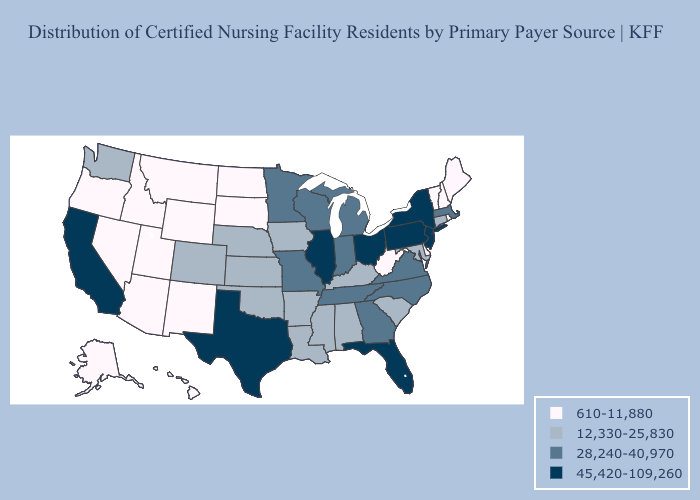What is the value of California?
Concise answer only. 45,420-109,260. Does the first symbol in the legend represent the smallest category?
Write a very short answer. Yes. What is the highest value in states that border Washington?
Answer briefly. 610-11,880. Name the states that have a value in the range 28,240-40,970?
Give a very brief answer. Georgia, Indiana, Massachusetts, Michigan, Minnesota, Missouri, North Carolina, Tennessee, Virginia, Wisconsin. Among the states that border North Dakota , does Montana have the highest value?
Answer briefly. No. What is the value of Massachusetts?
Write a very short answer. 28,240-40,970. What is the value of North Dakota?
Write a very short answer. 610-11,880. What is the value of New York?
Answer briefly. 45,420-109,260. What is the value of Connecticut?
Give a very brief answer. 12,330-25,830. What is the value of Iowa?
Write a very short answer. 12,330-25,830. Among the states that border Delaware , which have the highest value?
Keep it brief. New Jersey, Pennsylvania. What is the highest value in the USA?
Concise answer only. 45,420-109,260. What is the value of New Mexico?
Answer briefly. 610-11,880. 